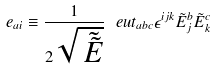Convert formula to latex. <formula><loc_0><loc_0><loc_500><loc_500>e _ { a i } \equiv \frac { 1 } { 2 \sqrt { \tilde { \, \tilde { E } } } } \, \ e u t _ { a b c } \epsilon ^ { i j k } \tilde { E } ^ { b } _ { j } \tilde { E } ^ { c } _ { k }</formula> 